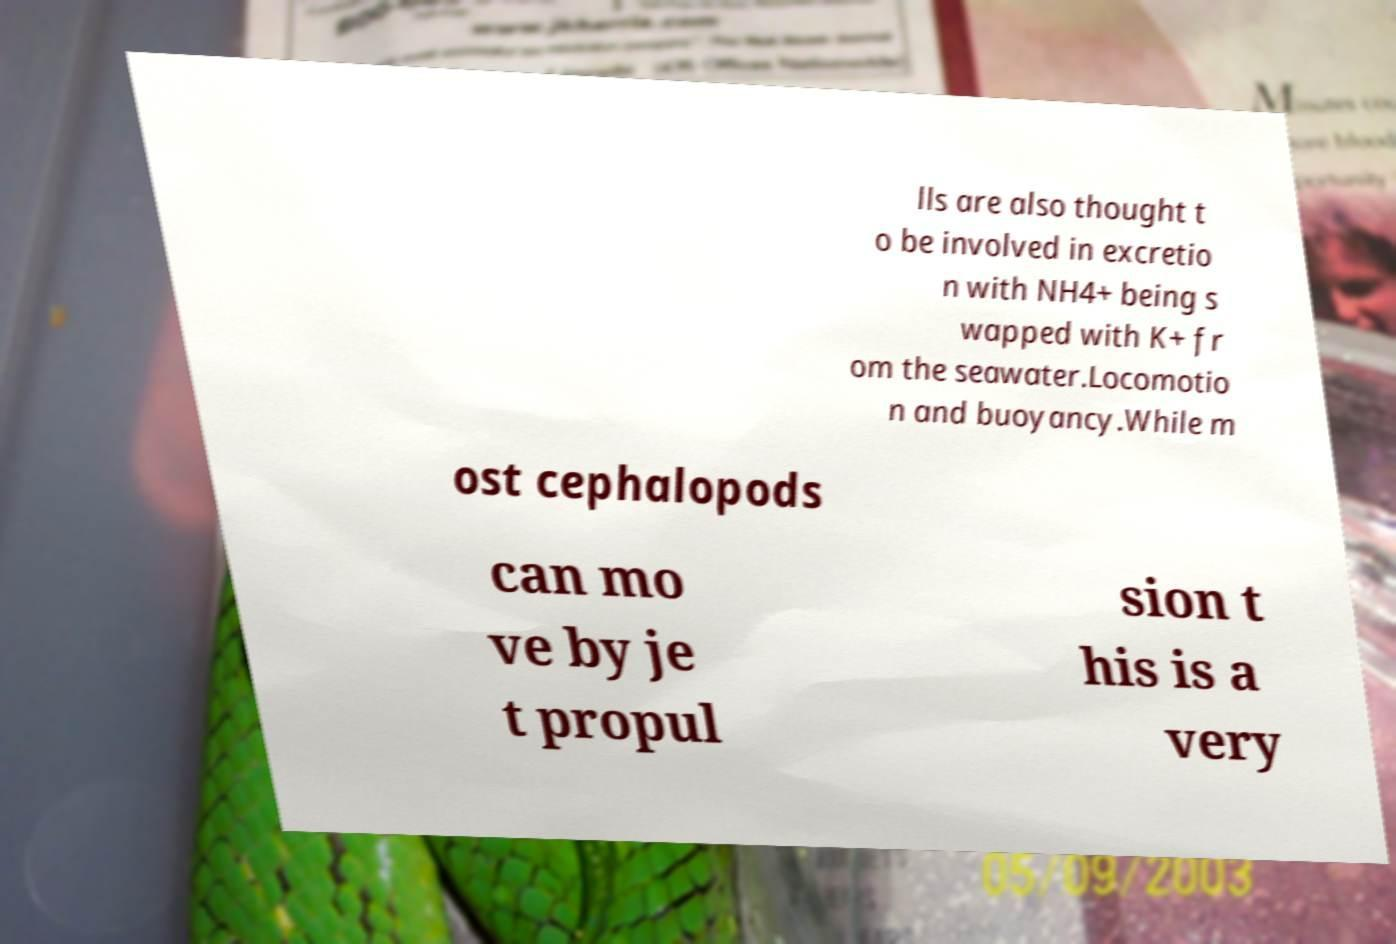Could you extract and type out the text from this image? lls are also thought t o be involved in excretio n with NH4+ being s wapped with K+ fr om the seawater.Locomotio n and buoyancy.While m ost cephalopods can mo ve by je t propul sion t his is a very 